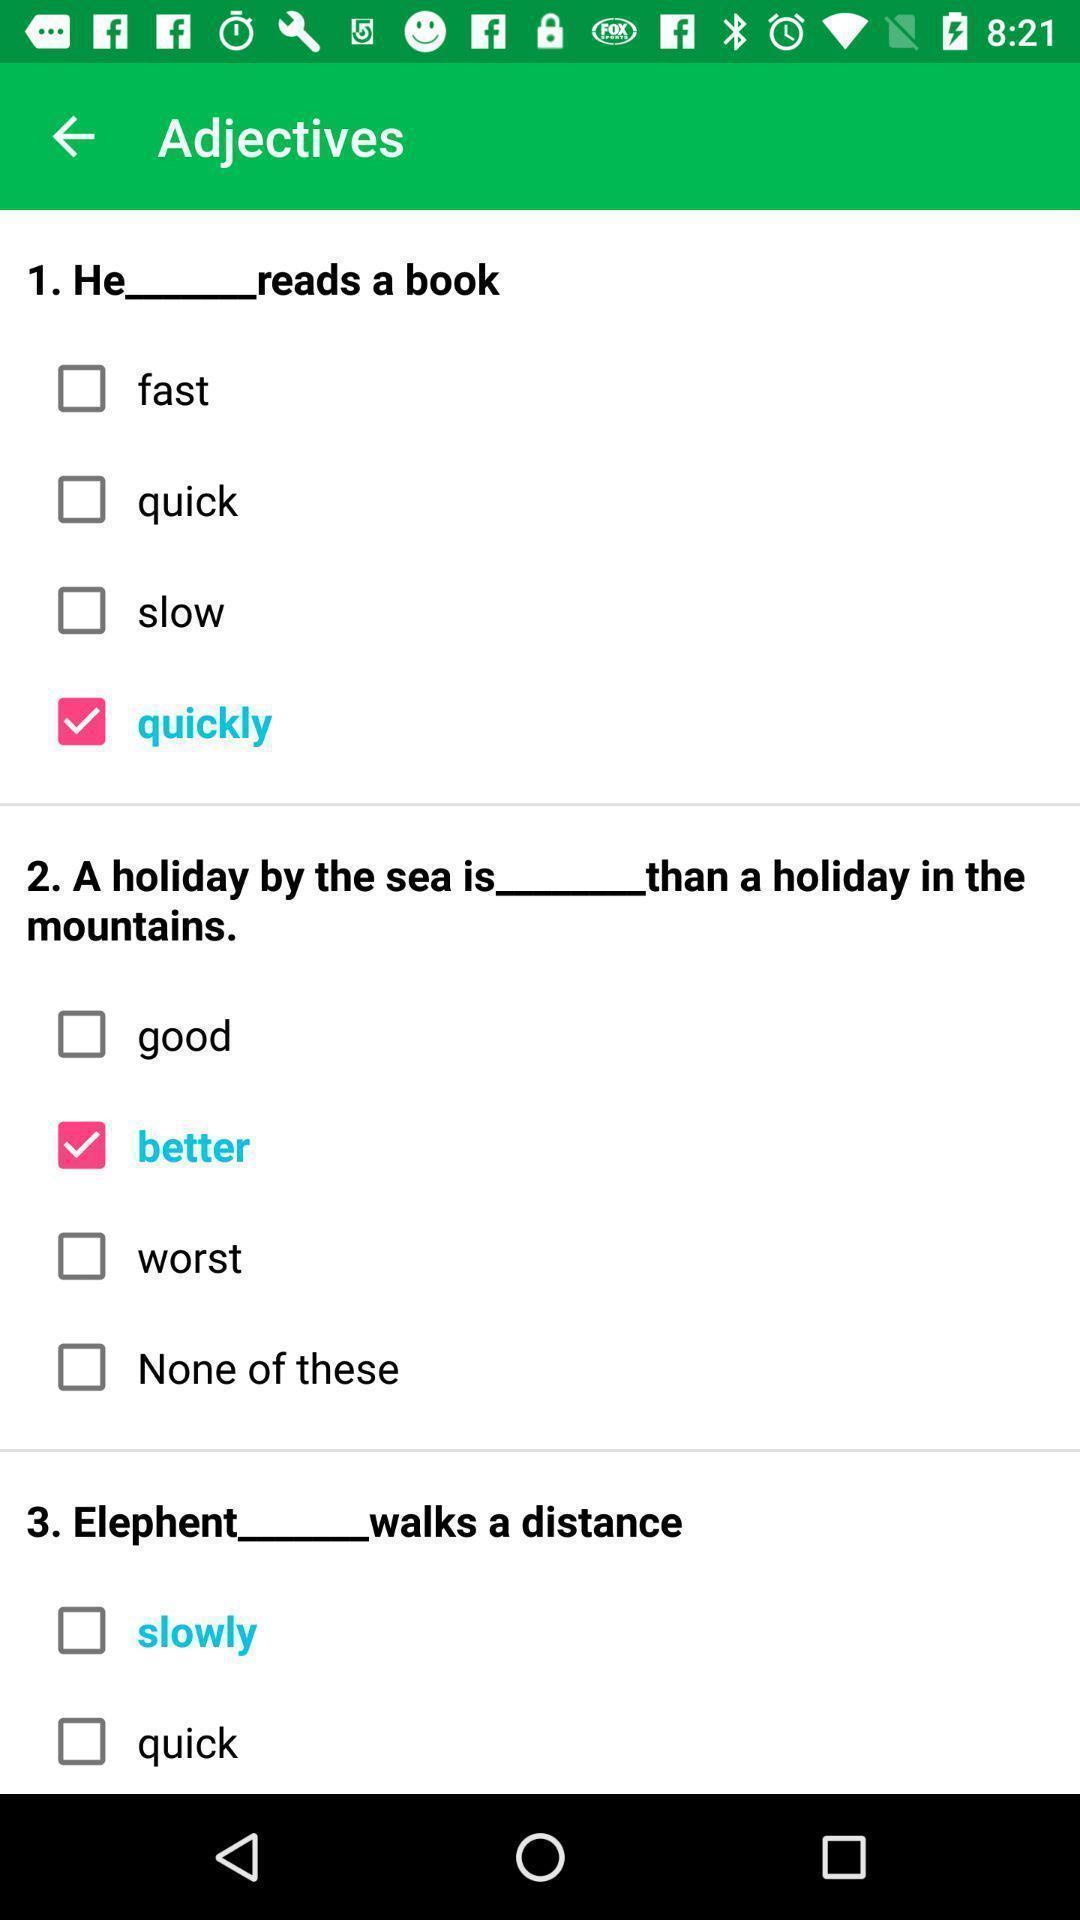Summarize the information in this screenshot. Screen shows list of adjectives in a learning app. 